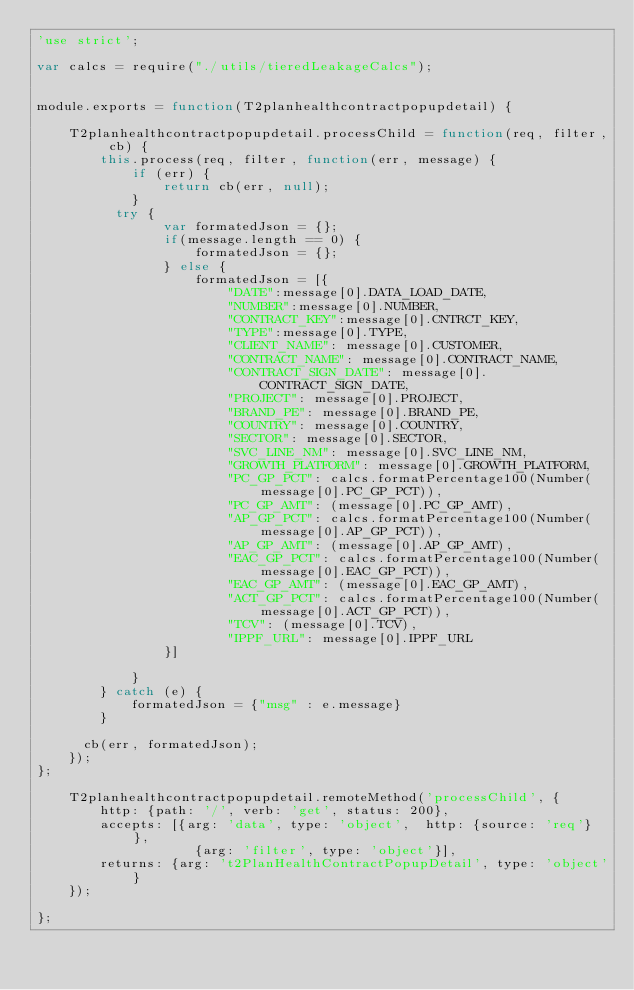<code> <loc_0><loc_0><loc_500><loc_500><_JavaScript_>'use strict';

var calcs = require("./utils/tieredLeakageCalcs");


module.exports = function(T2planhealthcontractpopupdetail) {

    T2planhealthcontractpopupdetail.processChild = function(req, filter, cb) {
        this.process(req, filter, function(err, message) {
            if (err) {
                return cb(err, null);
            }
          try {
                var formatedJson = {};
                if(message.length == 0) {
                    formatedJson = {};
                } else {
                    formatedJson = [{
                        "DATE":message[0].DATA_LOAD_DATE,
                        "NUMBER":message[0].NUMBER,
                        "CONTRACT_KEY":message[0].CNTRCT_KEY,                      
                        "TYPE":message[0].TYPE,
                        "CLIENT_NAME": message[0].CUSTOMER,
                        "CONTRACT_NAME": message[0].CONTRACT_NAME,
                        "CONTRACT_SIGN_DATE": message[0].CONTRACT_SIGN_DATE,
                        "PROJECT": message[0].PROJECT,
                        "BRAND_PE": message[0].BRAND_PE,
                        "COUNTRY": message[0].COUNTRY,
                        "SECTOR": message[0].SECTOR,
                        "SVC_LINE_NM": message[0].SVC_LINE_NM,
                        "GROWTH_PLATFORM": message[0].GROWTH_PLATFORM,
                        "PC_GP_PCT": calcs.formatPercentage100(Number(message[0].PC_GP_PCT)),
                        "PC_GP_AMT": (message[0].PC_GP_AMT),
                        "AP_GP_PCT": calcs.formatPercentage100(Number(message[0].AP_GP_PCT)),
                        "AP_GP_AMT": (message[0].AP_GP_AMT),
                        "EAC_GP_PCT": calcs.formatPercentage100(Number(message[0].EAC_GP_PCT)),
                        "EAC_GP_AMT": (message[0].EAC_GP_AMT),
                        "ACT_GP_PCT": calcs.formatPercentage100(Number(message[0].ACT_GP_PCT)),
                        "TCV": (message[0].TCV),
                        "IPPF_URL": message[0].IPPF_URL
                }]

            }
        } catch (e) {
            formatedJson = {"msg" : e.message}
        }
        
      cb(err, formatedJson);
    });
};

    T2planhealthcontractpopupdetail.remoteMethod('processChild', {
        http: {path: '/', verb: 'get', status: 200},
        accepts: [{arg: 'data', type: 'object',  http: {source: 'req'} },
                    {arg: 'filter', type: 'object'}],
        returns: {arg: 't2PlanHealthContractPopupDetail', type: 'object'}
    });

};
</code> 